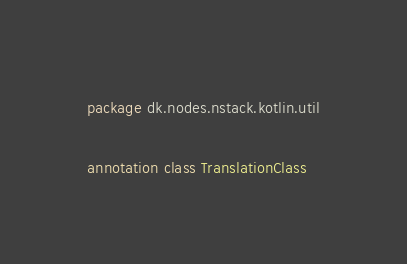Convert code to text. <code><loc_0><loc_0><loc_500><loc_500><_Kotlin_>package dk.nodes.nstack.kotlin.util

annotation class TranslationClass
</code> 